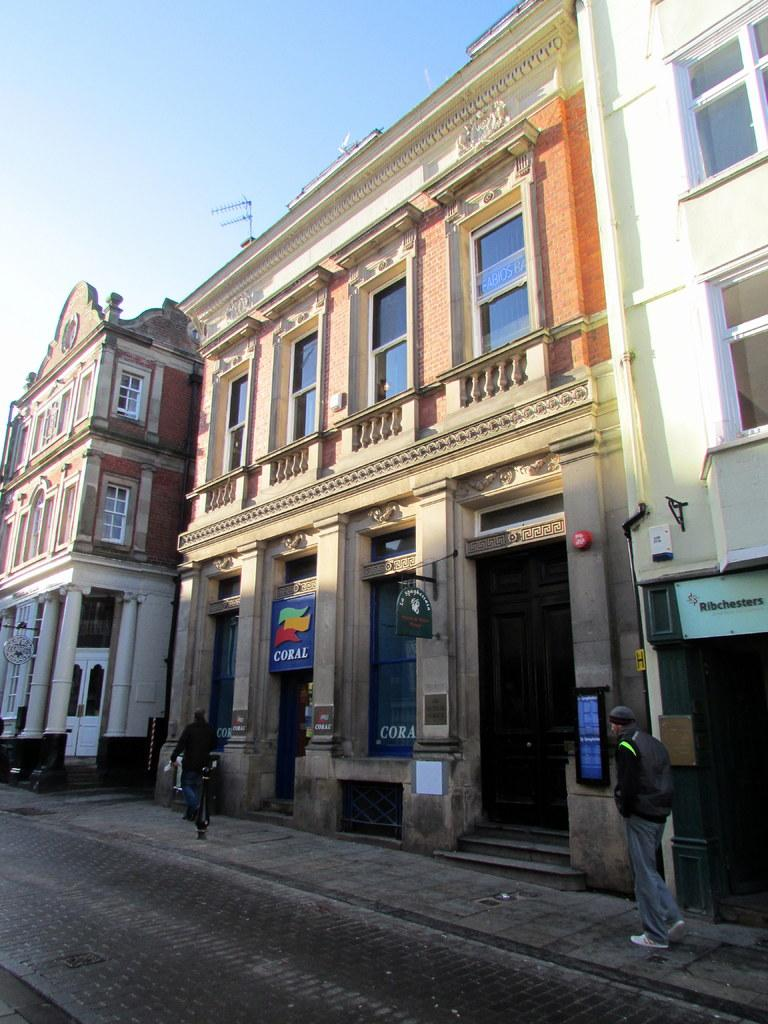What is located in the center of the image? There are buildings in the center of the image. What are the two persons at the bottom of the image doing? The two persons are walking at the bottom of the image. What is present at the bottom of the image besides the persons? There is a road at the bottom of the image. What can be seen at the top of the image? The sky is visible at the top of the image. Where is the coal mine located in the image? There is no coal mine present in the image. What type of clover can be seen growing on the road in the image? There is no clover present in the image; it features a road and buildings. 